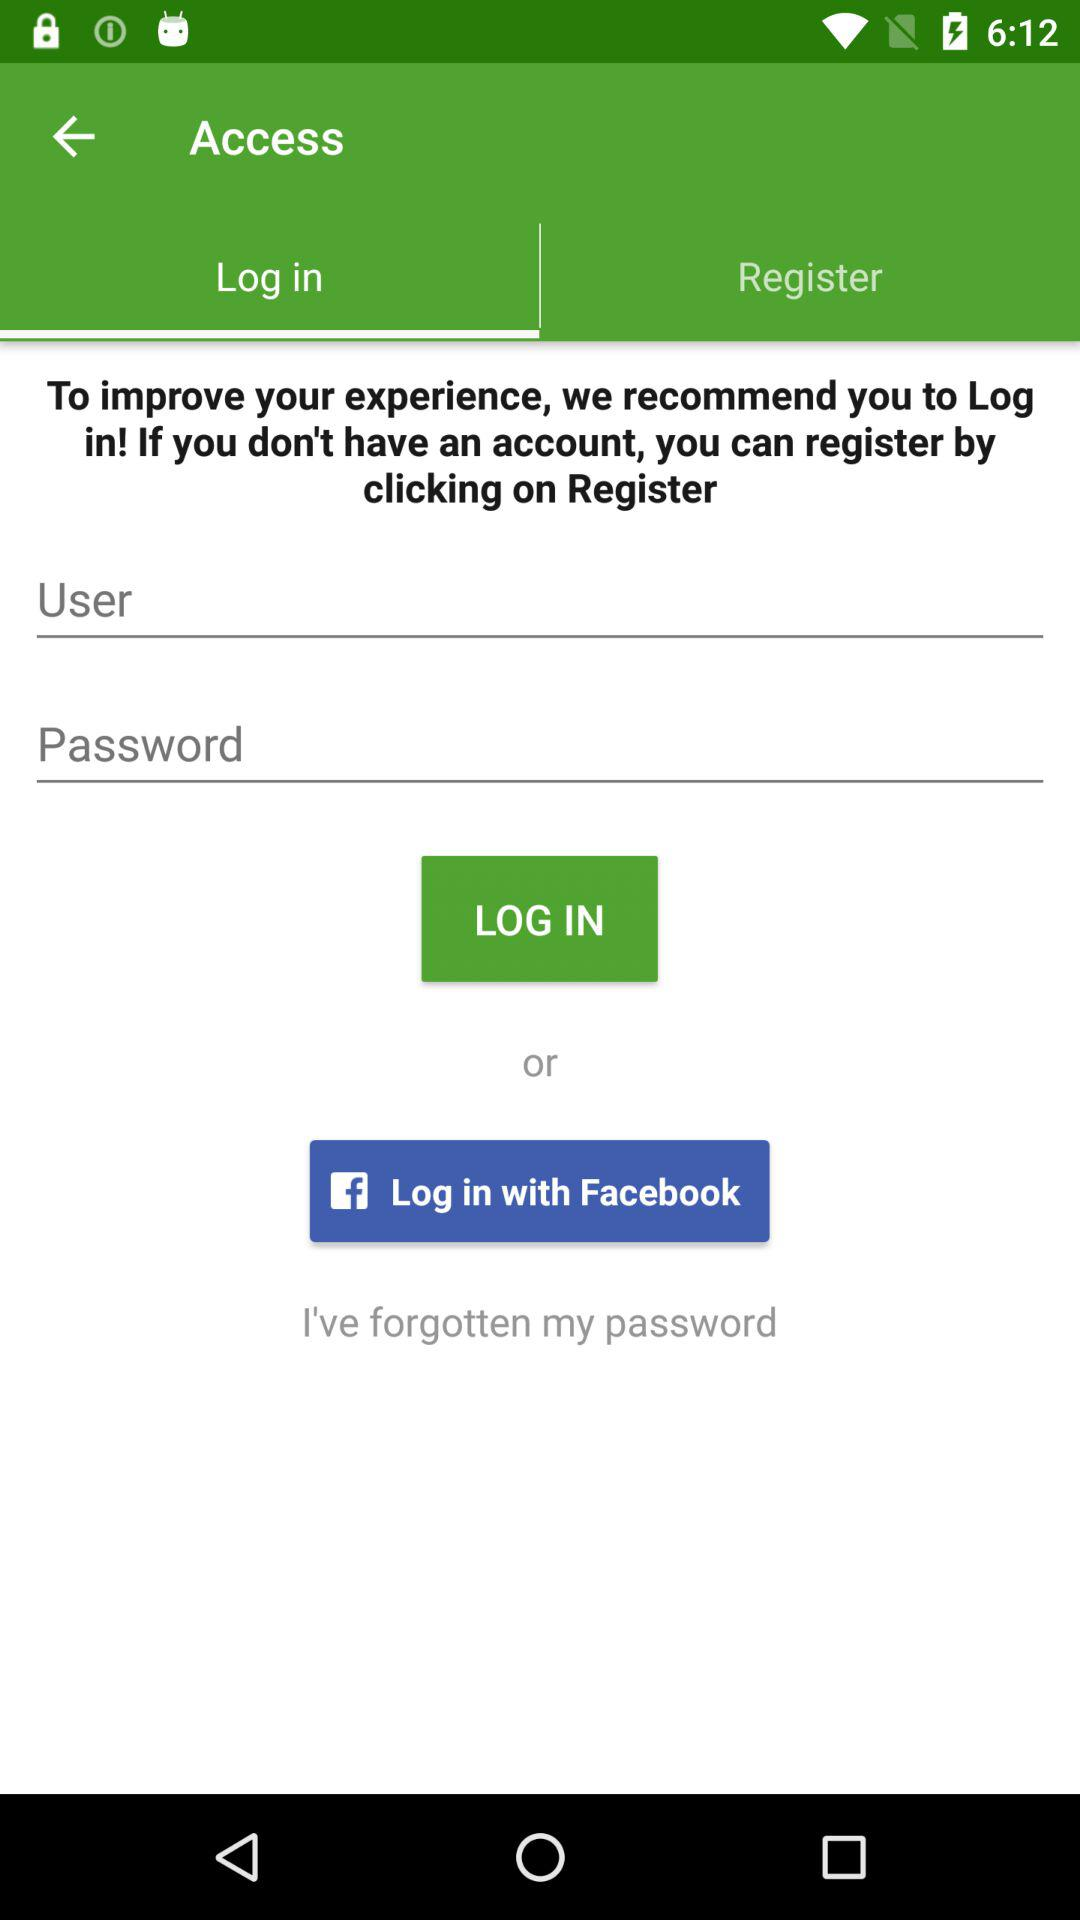Which tab is selected? The selected tab is "Log in". 